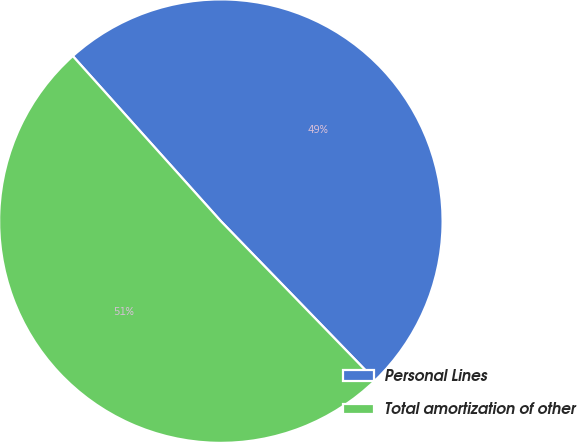Convert chart to OTSL. <chart><loc_0><loc_0><loc_500><loc_500><pie_chart><fcel>Personal Lines<fcel>Total amortization of other<nl><fcel>49.38%<fcel>50.62%<nl></chart> 